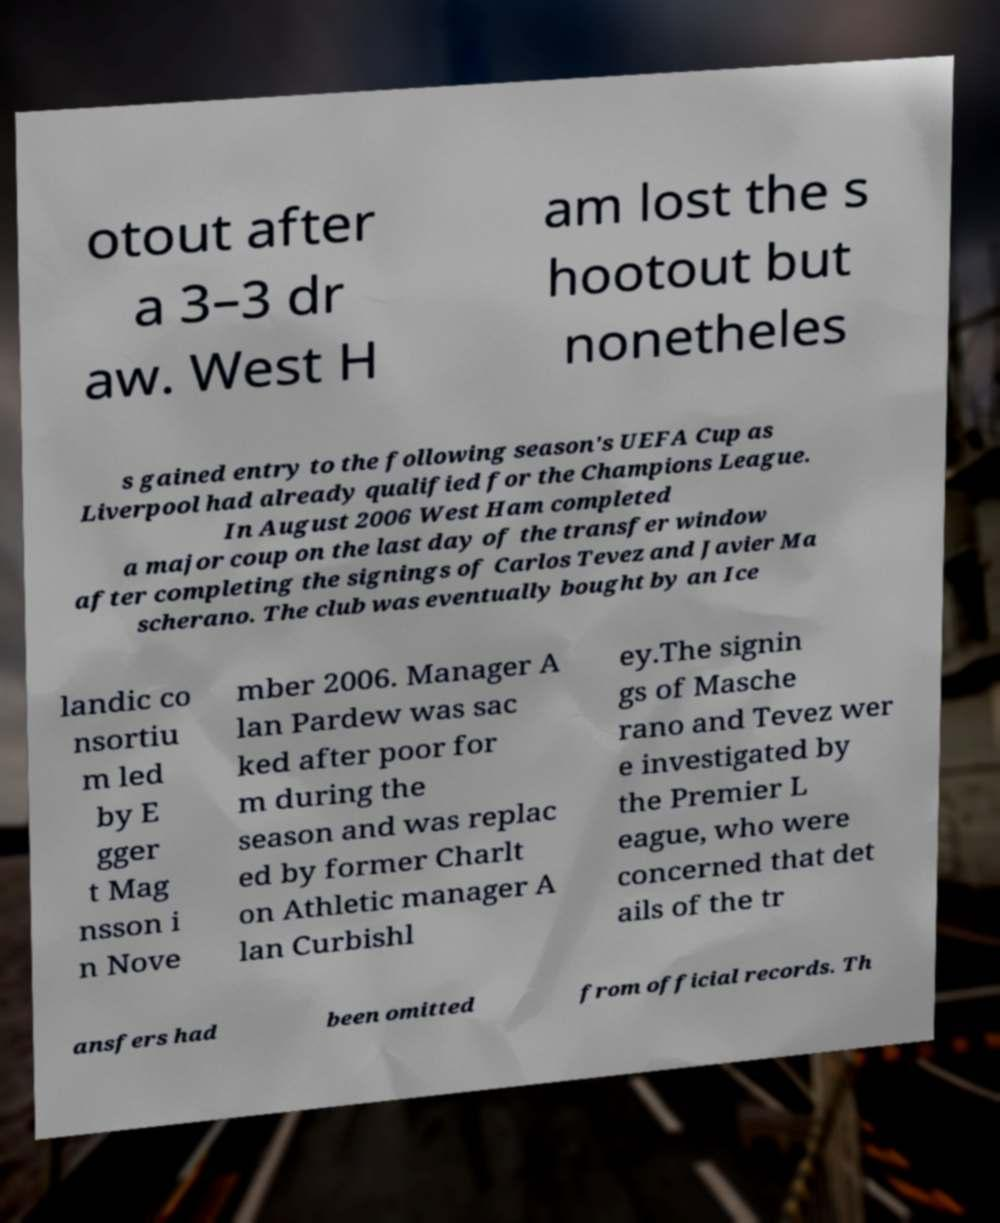For documentation purposes, I need the text within this image transcribed. Could you provide that? otout after a 3–3 dr aw. West H am lost the s hootout but nonetheles s gained entry to the following season's UEFA Cup as Liverpool had already qualified for the Champions League. In August 2006 West Ham completed a major coup on the last day of the transfer window after completing the signings of Carlos Tevez and Javier Ma scherano. The club was eventually bought by an Ice landic co nsortiu m led by E gger t Mag nsson i n Nove mber 2006. Manager A lan Pardew was sac ked after poor for m during the season and was replac ed by former Charlt on Athletic manager A lan Curbishl ey.The signin gs of Masche rano and Tevez wer e investigated by the Premier L eague, who were concerned that det ails of the tr ansfers had been omitted from official records. Th 